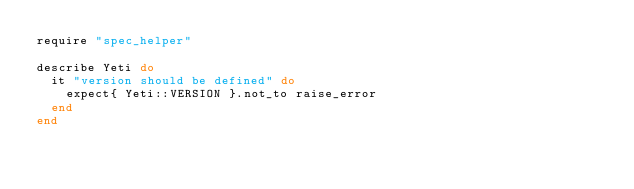Convert code to text. <code><loc_0><loc_0><loc_500><loc_500><_Ruby_>require "spec_helper"

describe Yeti do
  it "version should be defined" do
    expect{ Yeti::VERSION }.not_to raise_error
  end
end
</code> 